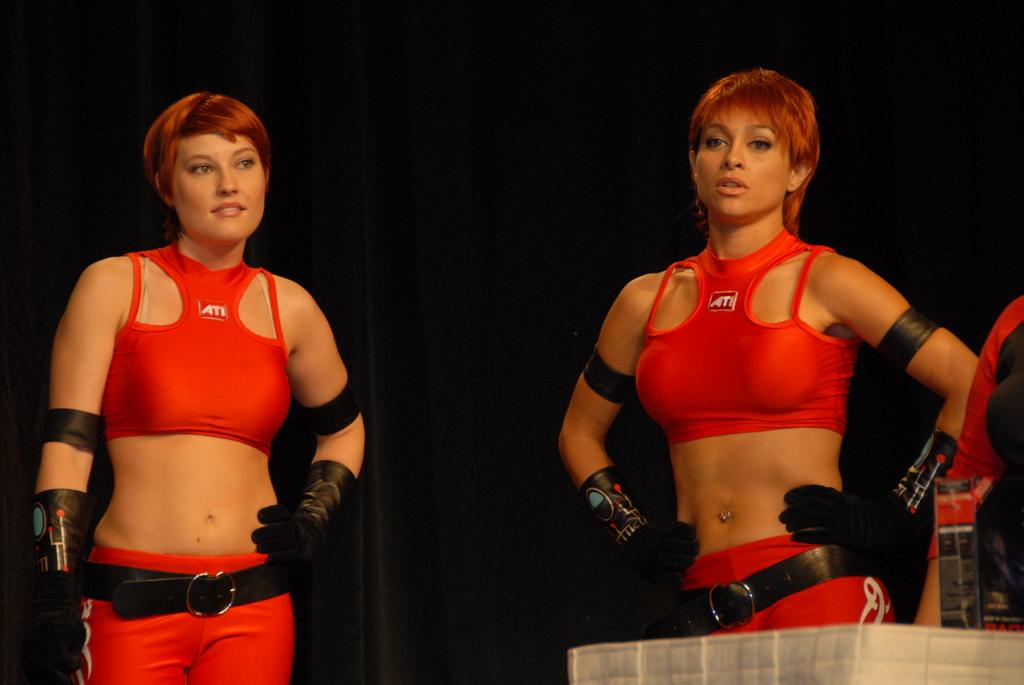What three letters are on their shirt?
Make the answer very short. Ati. 